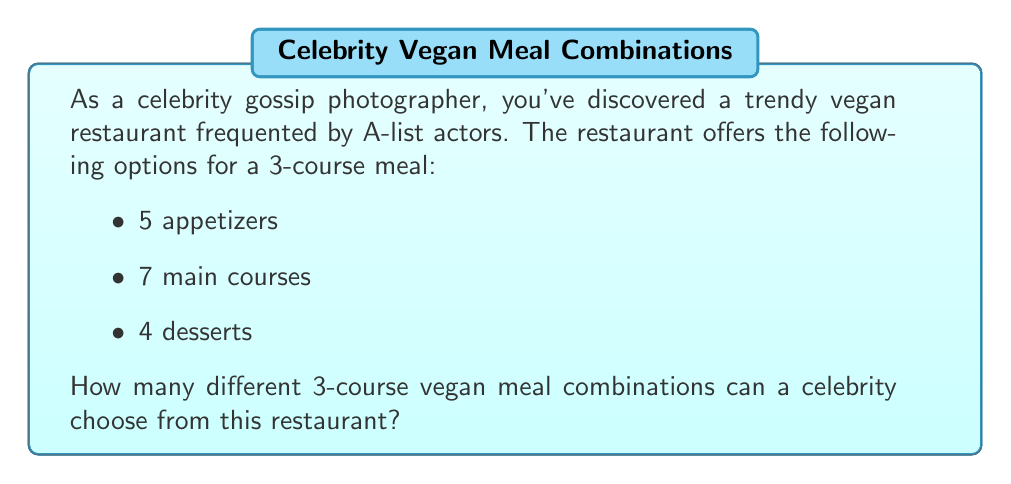Help me with this question. To solve this problem, we'll use the multiplication principle of counting.

1) For each course, the celebrity has independent choices:
   - 5 options for appetizers
   - 7 options for main courses
   - 4 options for desserts

2) According to the multiplication principle, when we have a sequence of independent choices, we multiply the number of options for each choice to get the total number of possible combinations.

3) Therefore, the total number of possible 3-course meal combinations is:

   $$ 5 \times 7 \times 4 $$

4) Let's calculate:
   $$ 5 \times 7 \times 4 = 35 \times 4 = 140 $$

Thus, there are 140 different possible 3-course vegan meal combinations a celebrity can choose from at this restaurant.
Answer: 140 possible meal combinations 